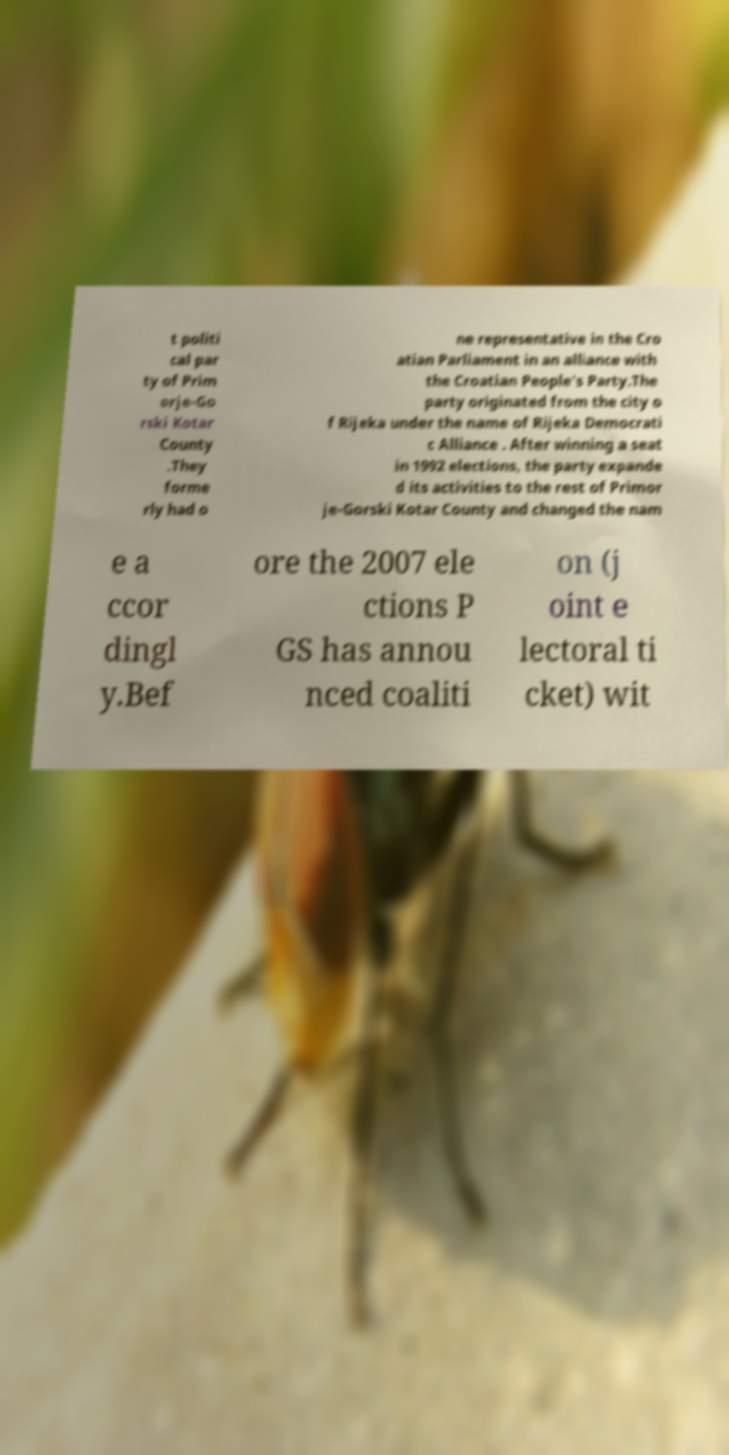Please identify and transcribe the text found in this image. t politi cal par ty of Prim orje-Go rski Kotar County .They forme rly had o ne representative in the Cro atian Parliament in an alliance with the Croatian People's Party.The party originated from the city o f Rijeka under the name of Rijeka Democrati c Alliance . After winning a seat in 1992 elections, the party expande d its activities to the rest of Primor je-Gorski Kotar County and changed the nam e a ccor dingl y.Bef ore the 2007 ele ctions P GS has annou nced coaliti on (j oint e lectoral ti cket) wit 